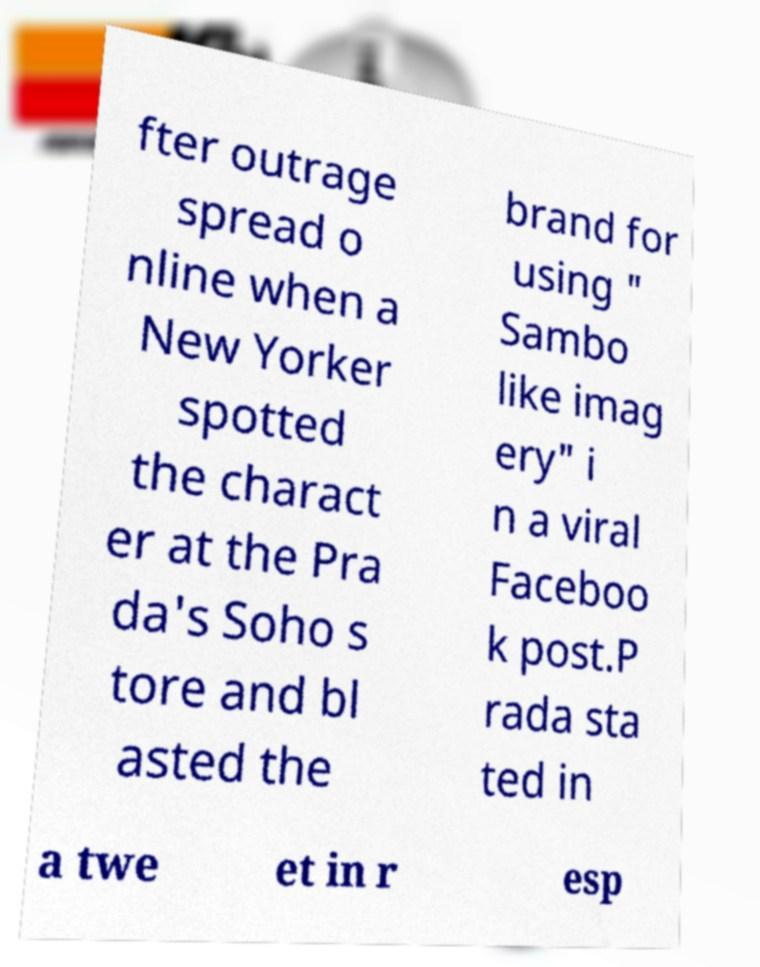Can you read and provide the text displayed in the image?This photo seems to have some interesting text. Can you extract and type it out for me? fter outrage spread o nline when a New Yorker spotted the charact er at the Pra da's Soho s tore and bl asted the brand for using " Sambo like imag ery" i n a viral Faceboo k post.P rada sta ted in a twe et in r esp 